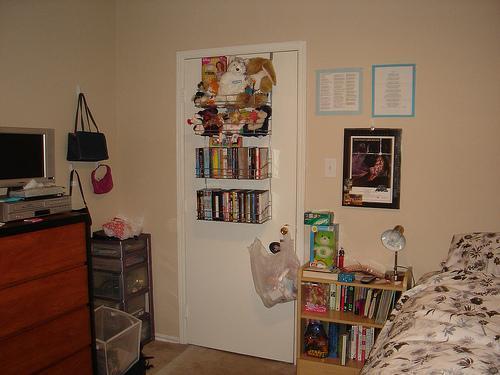How many purses are hanging on the wall?
Give a very brief answer. 3. 